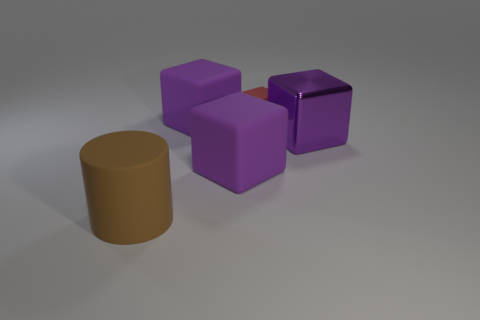What size is the brown thing that is the same material as the tiny cube?
Ensure brevity in your answer.  Large. How many rubber cubes have the same color as the metallic block?
Offer a very short reply. 2. How many other objects are there of the same shape as the purple shiny thing?
Keep it short and to the point. 3. There is a brown rubber cylinder; is its size the same as the rubber cube in front of the shiny cube?
Provide a succinct answer. Yes. What number of things are metallic blocks or big rubber cubes?
Give a very brief answer. 3. How many other things are the same size as the red rubber block?
Offer a terse response. 0. Do the metallic block and the big matte cube that is in front of the big shiny thing have the same color?
Provide a succinct answer. Yes. How many spheres are purple things or big purple metallic things?
Ensure brevity in your answer.  0. Is there any other thing of the same color as the tiny block?
Make the answer very short. No. There is a big purple cube on the right side of the rubber block in front of the purple metallic thing; what is its material?
Your answer should be very brief. Metal. 